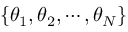<formula> <loc_0><loc_0><loc_500><loc_500>\{ \theta _ { 1 } , \theta _ { 2 } , \cdots , \theta _ { N } \}</formula> 